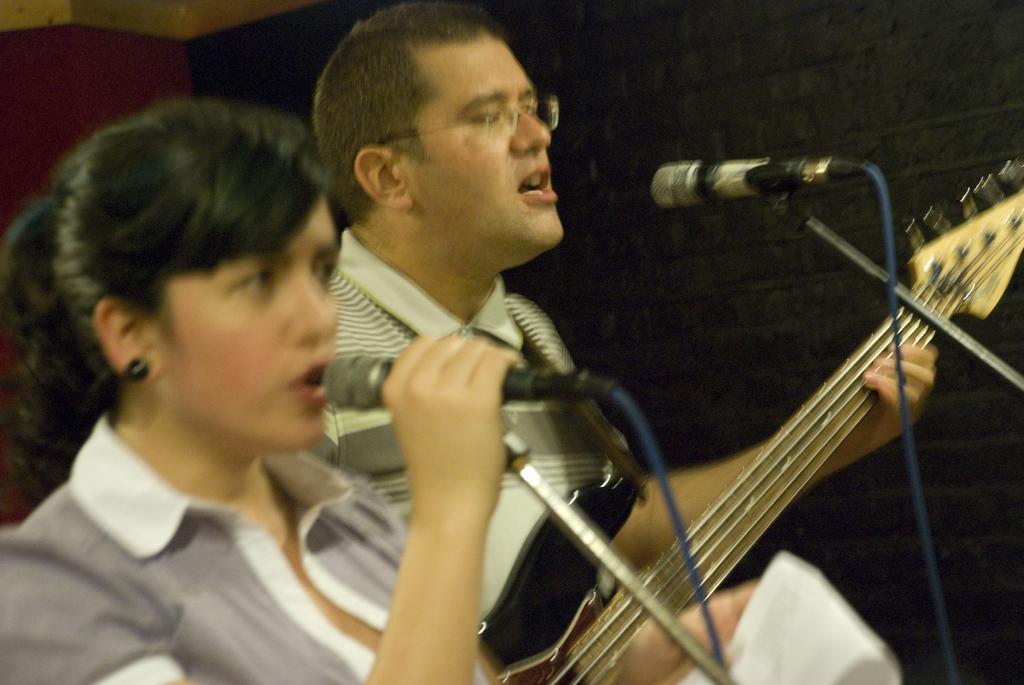Can you describe this image briefly? In this picture we can see two persons, in the left side of the image a woman is singing with the help of microphone and she is holding a paper in her hand, and the man is playing guitar in front of microphone. 